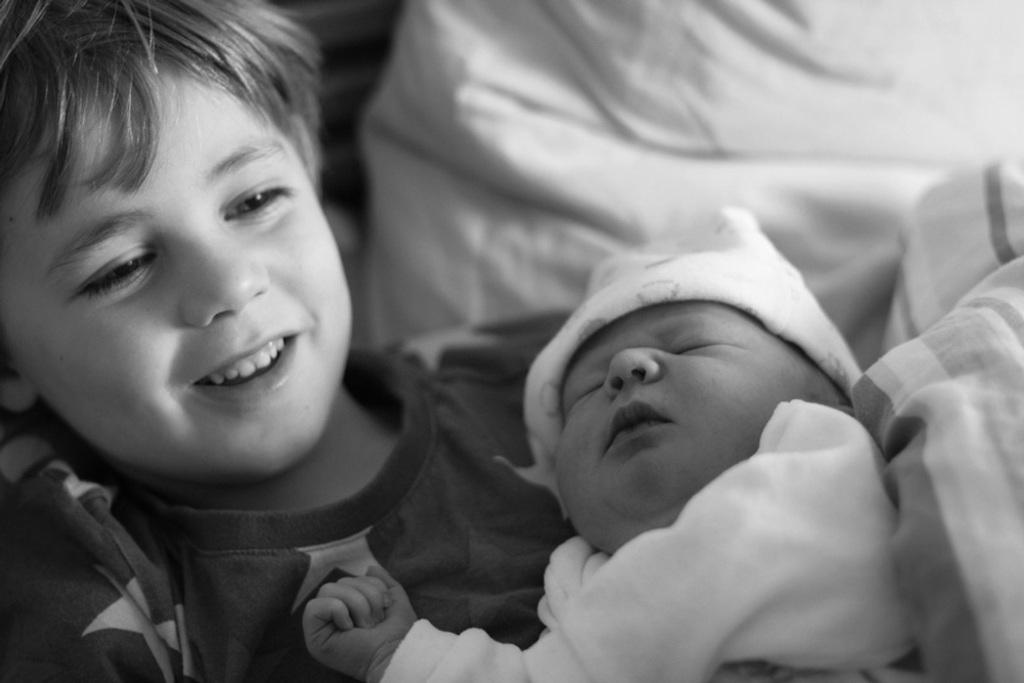What is the color scheme of the image? The image is black and white. Who is the main subject in the image? There is a boy in the image. What is the boy doing in the image? The boy is carrying a baby. What can be seen in the background of the image? There is a white color cloth in the background of the image. What type of cub is playing with the baby in the image? There is no cub present in the image, and the baby is being carried by the boy, not playing with any animal. 